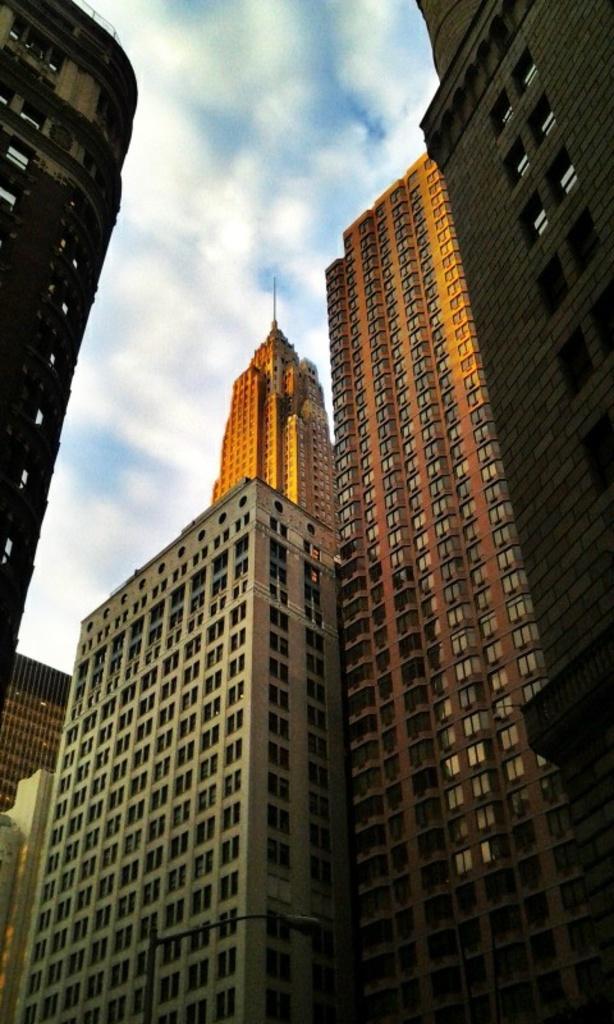In one or two sentences, can you explain what this image depicts? In this image I can see number of buildings in the front and on the bottom side I can see a pole and a street light. In the background I can see clouds and the sky. 